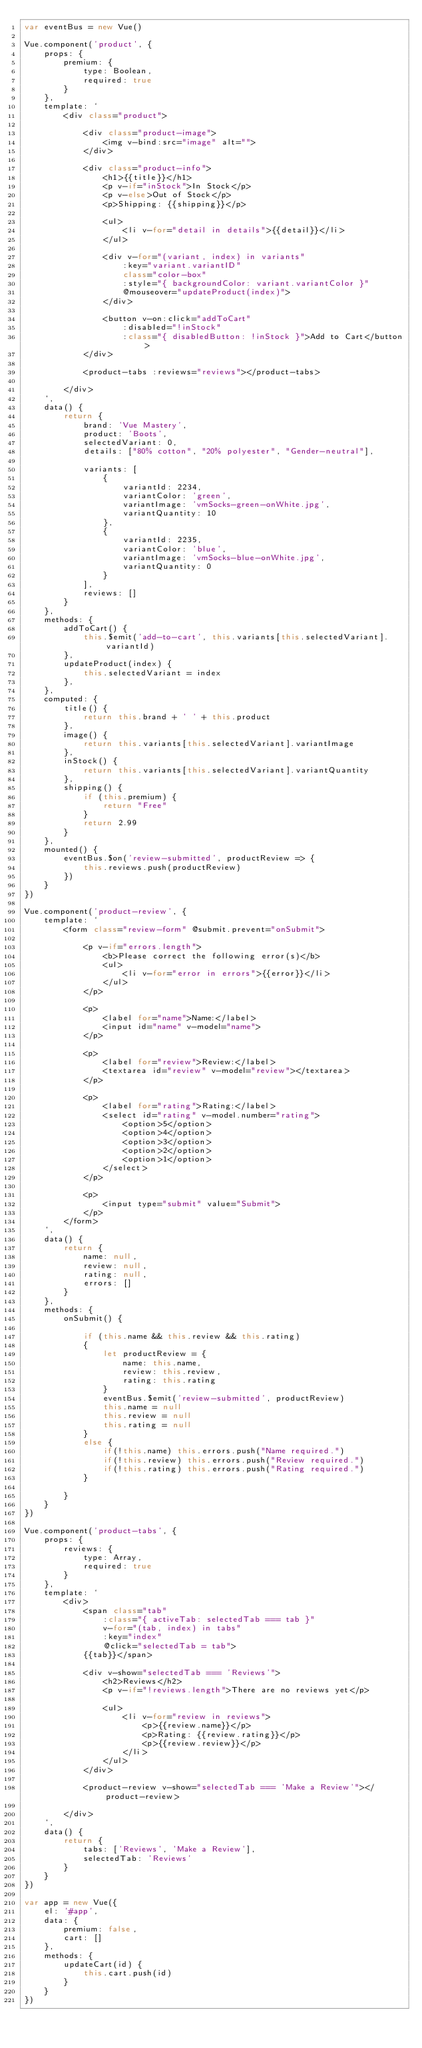Convert code to text. <code><loc_0><loc_0><loc_500><loc_500><_JavaScript_>var eventBus = new Vue()

Vue.component('product', {
    props: {
        premium: {
            type: Boolean,
            required: true
        }
    },
    template: `
        <div class="product">

            <div class="product-image">
                <img v-bind:src="image" alt="">
            </div>

            <div class="product-info">
                <h1>{{title}}</h1>
                <p v-if="inStock">In Stock</p>
                <p v-else>Out of Stock</p>
                <p>Shipping: {{shipping}}</p>

                <ul>
                    <li v-for="detail in details">{{detail}}</li>
                </ul>

                <div v-for="(variant, index) in variants"
                    :key="variant.variantID"
                    class="color-box"
                    :style="{ backgroundColor: variant.variantColor }"
                    @mouseover="updateProduct(index)">
                </div>

                <button v-on:click="addToCart"
                    :disabled="!inStock"
                    :class="{ disabledButton: !inStock }">Add to Cart</button>
            </div>

            <product-tabs :reviews="reviews"></product-tabs>

        </div>
    `,
    data() {
        return {
            brand: 'Vue Mastery',
            product: 'Boots',
            selectedVariant: 0,
            details: ["80% cotton", "20% polyester", "Gender-neutral"],
        
            variants: [
                {
                    variantId: 2234,
                    variantColor: 'green',
                    variantImage: 'vmSocks-green-onWhite.jpg',
                    variantQuantity: 10
                },
                {
                    variantId: 2235,
                    variantColor: 'blue',
                    variantImage: 'vmSocks-blue-onWhite.jpg',
                    variantQuantity: 0
                }
            ],
            reviews: []
        }
    },
    methods: {
        addToCart() {
            this.$emit('add-to-cart', this.variants[this.selectedVariant].variantId)
        },
        updateProduct(index) {
            this.selectedVariant = index
        },
    },
    computed: {
        title() {
            return this.brand + ' ' + this.product
        },
        image() {
            return this.variants[this.selectedVariant].variantImage
        },
        inStock() {
            return this.variants[this.selectedVariant].variantQuantity
        },
        shipping() {
            if (this.premium) {
                return "Free"
            }
            return 2.99
        }
    },
    mounted() {
        eventBus.$on('review-submitted', productReview => {
            this.reviews.push(productReview)
        })
    }
})

Vue.component('product-review', {
    template: `
        <form class="review-form" @submit.prevent="onSubmit">

            <p v-if="errors.length">
                <b>Please correct the following error(s)</b>
                <ul>
                    <li v-for="error in errors">{{error}}</li>
                </ul>
            </p>

            <p>
                <label for="name">Name:</label>
                <input id="name" v-model="name">
            </p>

            <p>
                <label for="review">Review:</label>
                <textarea id="review" v-model="review"></textarea>
            </p>

            <p>
                <label for="rating">Rating:</label>
                <select id="rating" v-model.number="rating">
                    <option>5</option>
                    <option>4</option>
                    <option>3</option>
                    <option>2</option>
                    <option>1</option>
                </select>
            </p>

            <p>
                <input type="submit" value="Submit">
            </p>
        </form>
    `,
    data() {
        return {
            name: null,
            review: null,
            rating: null,
            errors: []
        }
    },
    methods: {
        onSubmit() {

            if (this.name && this.review && this.rating)
            {
                let productReview = {
                    name: this.name,
                    review: this.review,
                    rating: this.rating
                }
                eventBus.$emit('review-submitted', productReview)
                this.name = null
                this.review = null
                this.rating = null
            }
            else {
                if(!this.name) this.errors.push("Name required.")
                if(!this.review) this.errors.push("Review required.")
                if(!this.rating) this.errors.push("Rating required.")
            }
            
        }
    }
})

Vue.component('product-tabs', {
    props: {
        reviews: {
            type: Array,
            required: true
        }
    },
    template: `
        <div>
            <span class="tab"
                :class="{ activeTab: selectedTab === tab }"
                v-for="(tab, index) in tabs"
                :key="index"
                @click="selectedTab = tab">
            {{tab}}</span>

            <div v-show="selectedTab === 'Reviews'">
                <h2>Reviews</h2>
                <p v-if="!reviews.length">There are no reviews yet</p>

                <ul>
                    <li v-for="review in reviews">
                        <p>{{review.name}}</p>
                        <p>Rating: {{review.rating}}</p>
                        <p>{{review.review}}</p>
                    </li>
                </ul>
            </div>

            <product-review v-show="selectedTab === 'Make a Review'"></product-review>

        </div>
    `,
    data() {
        return {
            tabs: ['Reviews', 'Make a Review'],
            selectedTab: 'Reviews'
        }
    }
})

var app = new Vue({
    el: '#app',
    data: {
        premium: false,
        cart: []
    },
    methods: {
        updateCart(id) {
            this.cart.push(id)
        }
    }
})</code> 